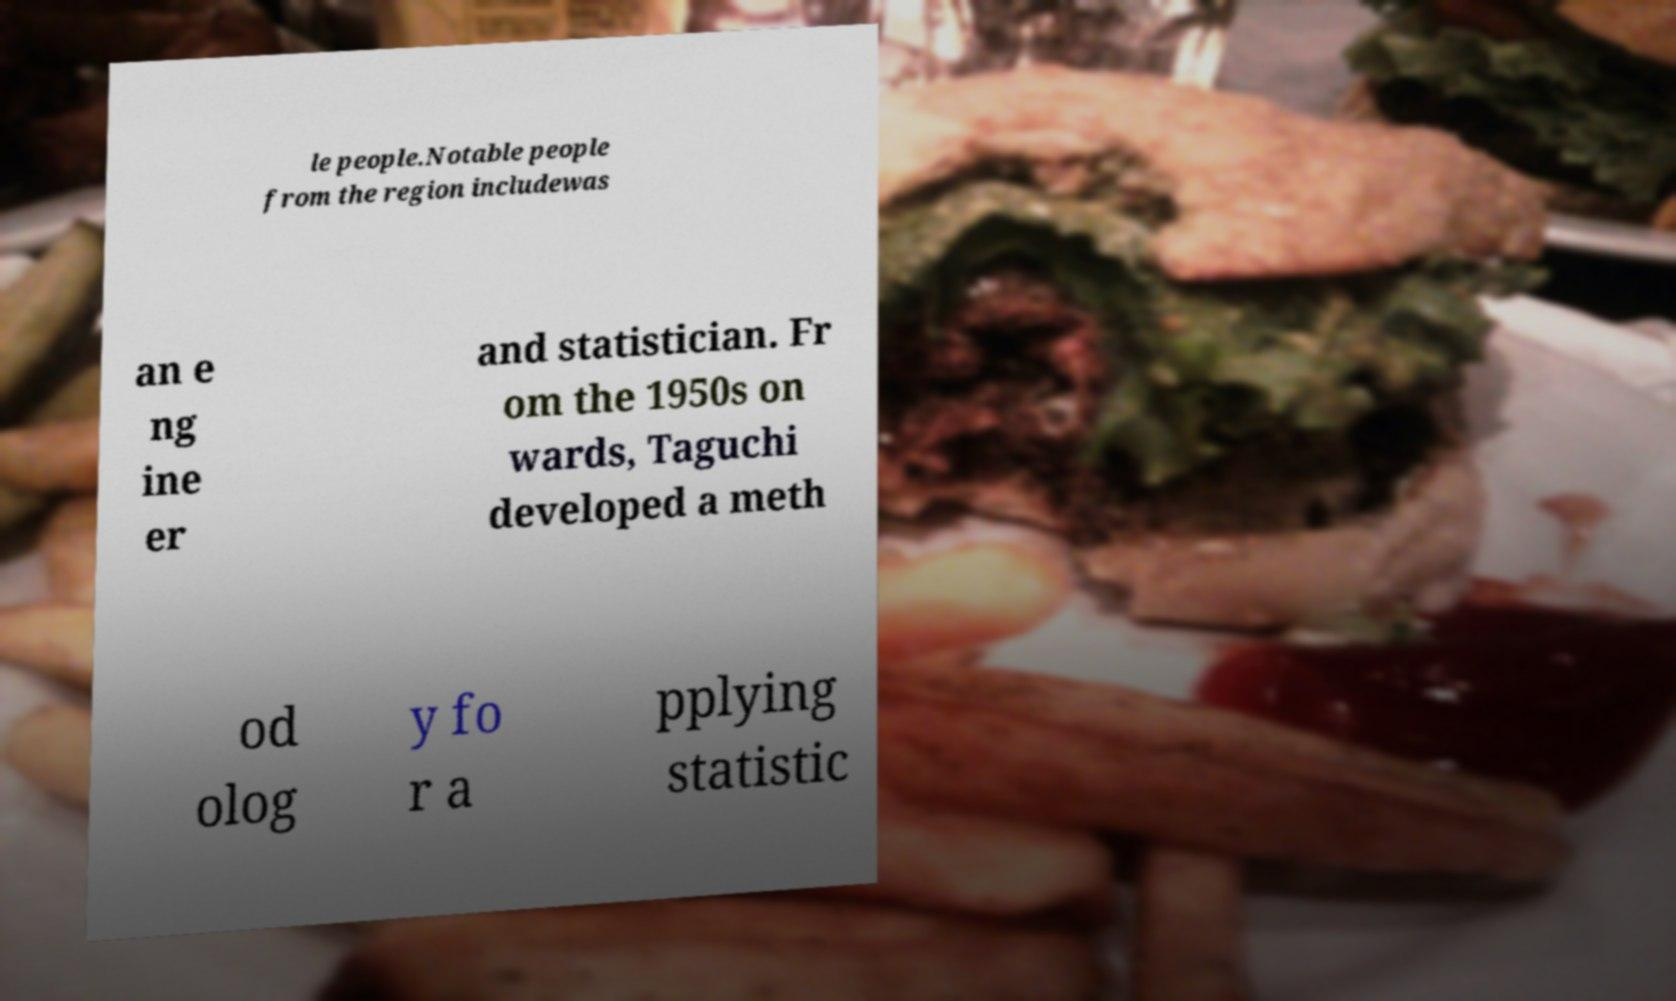I need the written content from this picture converted into text. Can you do that? le people.Notable people from the region includewas an e ng ine er and statistician. Fr om the 1950s on wards, Taguchi developed a meth od olog y fo r a pplying statistic 